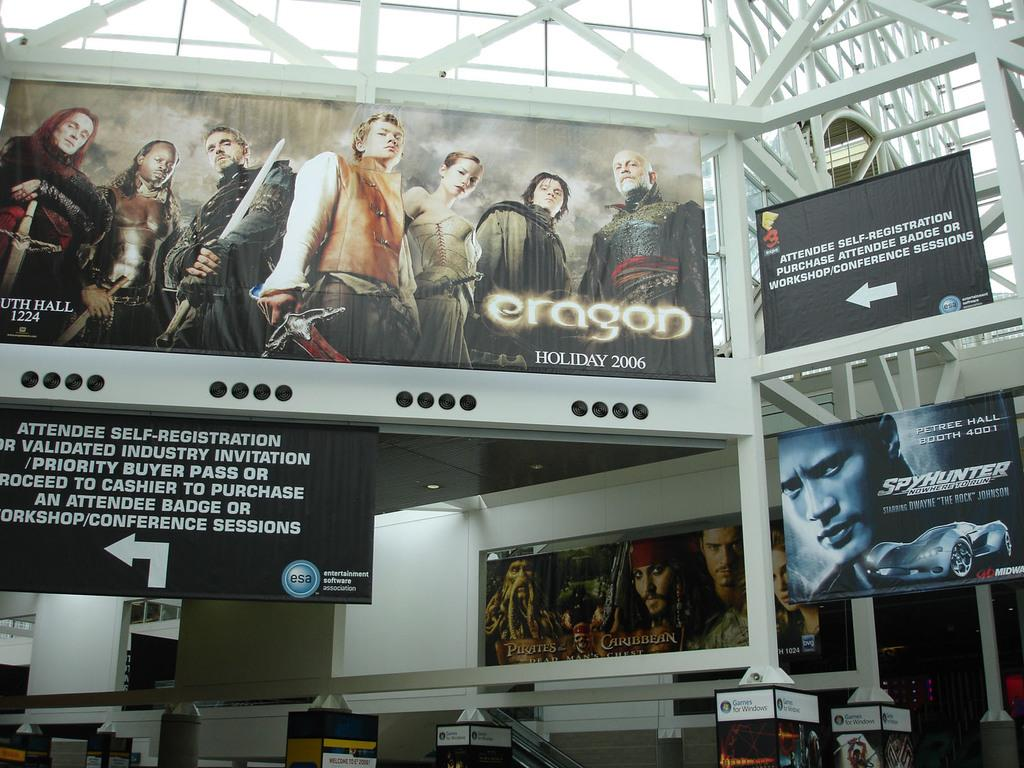What type of signage is present in the image? There are banners and hoardings in the image. How are the banners and hoardings attached in the image? The banners and hoardings are attached to iron rods and a wall. What type of prison is depicted on the banners in the image? There are no prisons depicted on the banners in the image; they feature banners and hoardings with other content. How does the oven function in the image? There is no oven present in the image. 